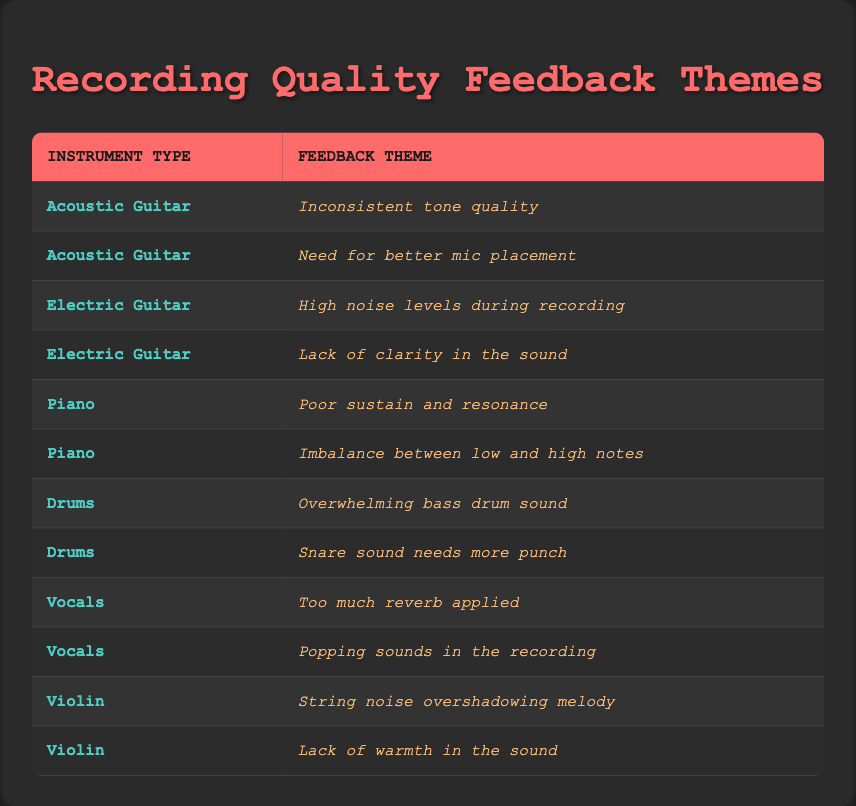What instrument has the most feedback themes listed? There are multiple instrument types mentioned in the table, along with their associated feedback themes. I will count the number of feedback themes for each instrument type: Acoustic Guitar has 2, Electric Guitar has 2, Piano has 2, Drums has 2, Vocals has 2, and Violin has 2. Since all instrument types have the same number of feedback themes, there is no single instrument with the most feedback themes.
Answer: None Is there any feedback related to Electric Guitars concerning sound clarity? The table lists two feedback themes for Electric Guitars: "High noise levels during recording" and "Lack of clarity in the sound." The second theme explicitly mentions clarity issues, confirming the feedback is about sound clarity.
Answer: Yes What is the total number of unique instruments mentioned in the feedback? Looking at the table, the instrument types mentioned are Acoustic Guitar, Electric Guitar, Piano, Drums, Vocals, and Violin. I will count these distinct instrument types, which gives me a total of 6 unique instruments.
Answer: 6 Which instrument has a feedback theme related to "reverb"? The table shows a feedback theme stating "Too much reverb applied," which is associated with Vocals. Thus, the only instrument having a feedback theme related to reverb is Vocals.
Answer: Vocals How many feedback themes mention issues with low and high notes? The feedback theme stating “Imbalance between low and high notes” is associated with Piano. This is the only theme that mentions low and high notes, hence the total is 1.
Answer: 1 Is there any instrument type that has feedback about bass drum sound? The feedback theme “Overwhelming bass drum sound” is connected to Drums, indicating that there is indeed feedback related to bass drum sound.
Answer: Yes What feedback is indicated regarding Violin’s sound quality? The Violin has two feedback themes: “String noise overshadowing melody” and “Lack of warmth in the sound.” Therefore, both themes indicate issues with Violin's sound quality.
Answer: 2 themes Overall, which instrument type has the least amount of feedback provided? After counting, all instrument types have exactly 2 feedback themes listed. Therefore, no instrument type has fewer themes than the others, meaning they all have equal feedback.
Answer: None 